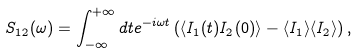<formula> <loc_0><loc_0><loc_500><loc_500>S _ { 1 2 } ( \omega ) = \int _ { - \infty } ^ { + \infty } d t e ^ { - i \omega t } \left ( \langle I _ { 1 } ( t ) I _ { 2 } ( 0 ) \rangle - \langle I _ { 1 } \rangle \langle I _ { 2 } \rangle \right ) ,</formula> 